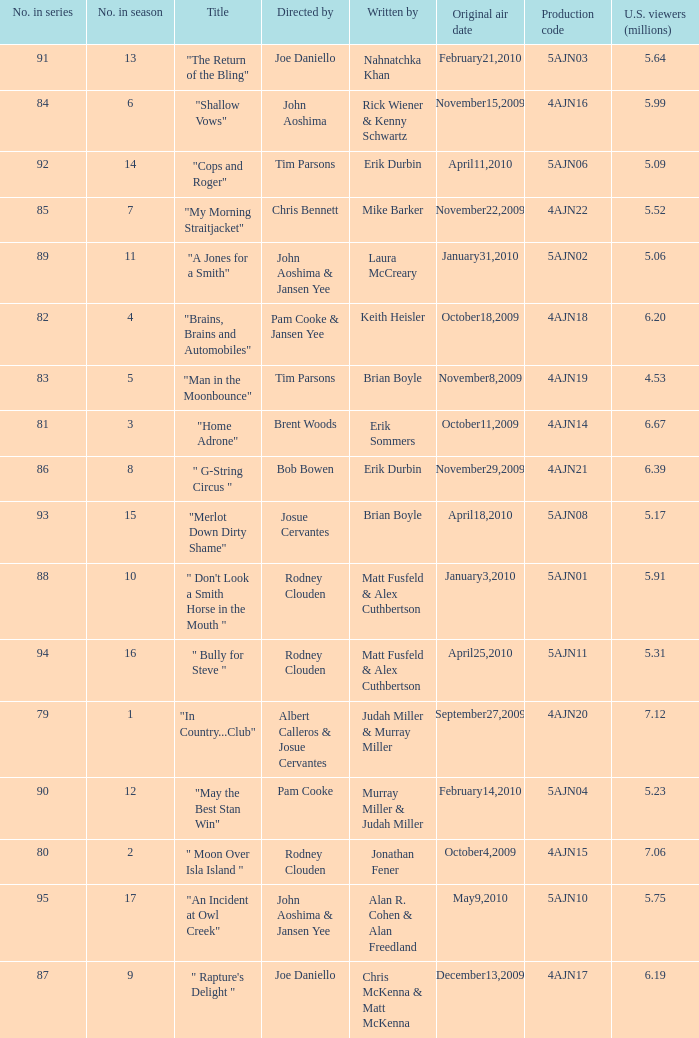Name the original air date for " don't look a smith horse in the mouth " January3,2010. 